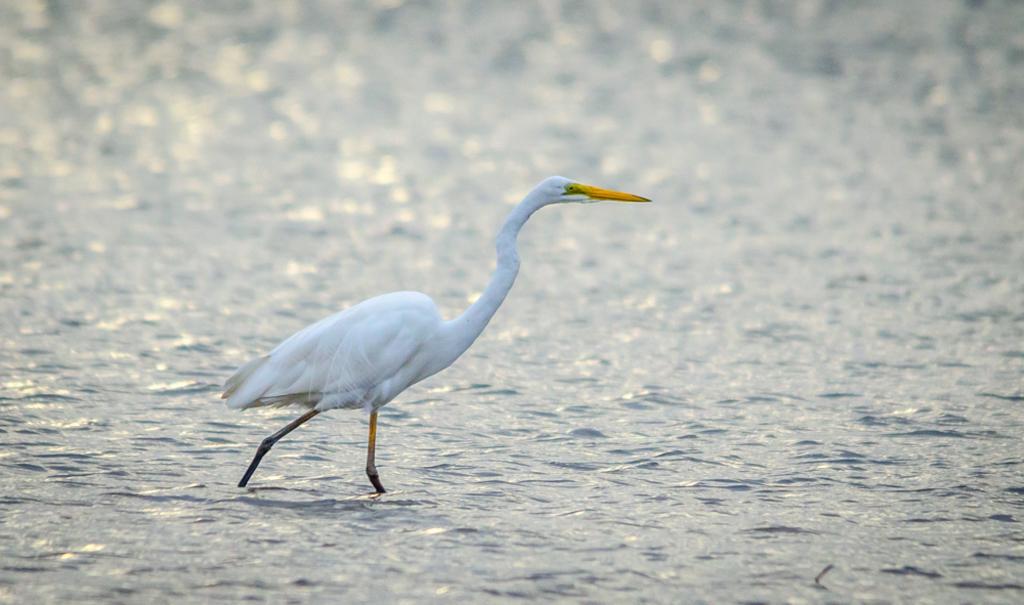Can you describe this image briefly? In this image, we can see a crane in the water. In the background, image is blurred. 